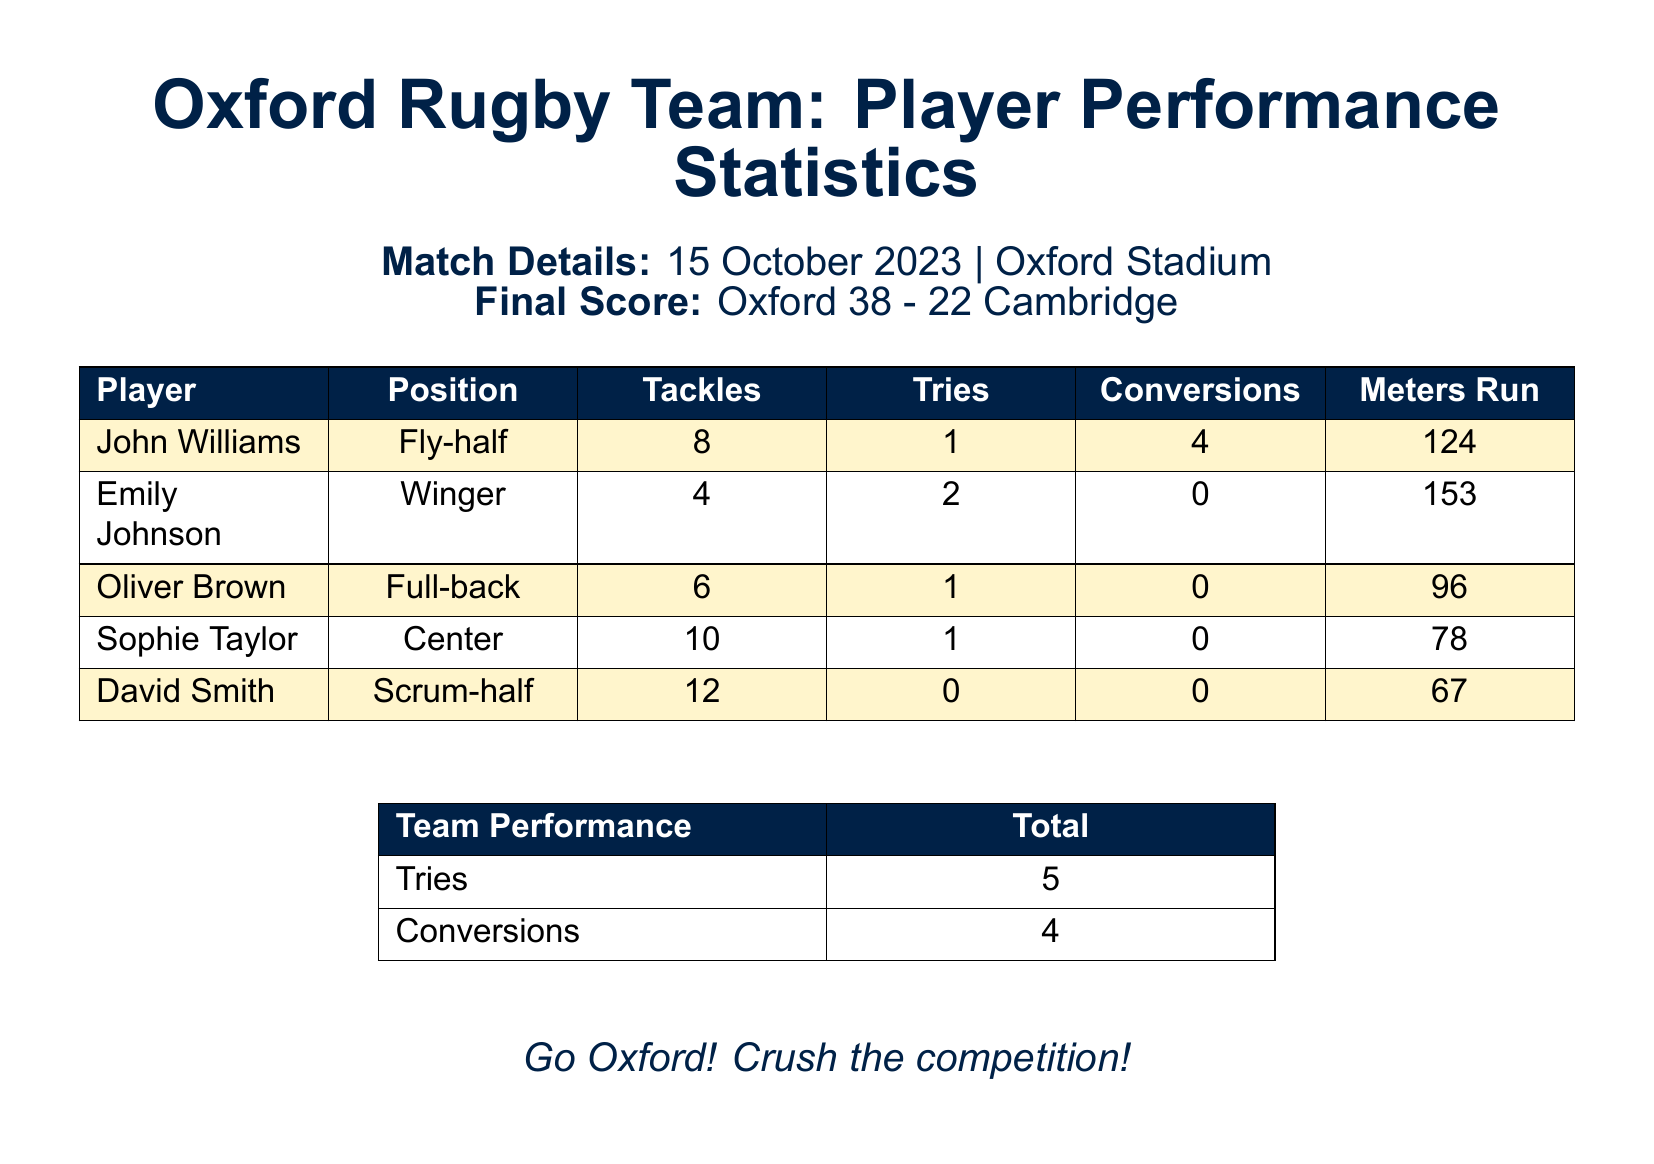What was the final score of the match? The final score of the match is explicitly stated in the document under match details.
Answer: Oxford 38 - 22 Cambridge How many tries did Oxford score? The total tries scored by Oxford is mentioned in the team performance section of the scorecard.
Answer: 5 Who had the highest number of tackles? The player with the highest number of tackles can be determined by comparing the tackle counts listed for each player.
Answer: David Smith How many conversions did John Williams make? The number of conversions made by John Williams is directly listed in his statistics section in the scorecard.
Answer: 4 What position does Emily Johnson play? The position of Emily Johnson is provided in the player statistics table.
Answer: Winger Which player ran the most meters? The player who ran the most meters can be identified by looking at the meters run column in the scorecard.
Answer: Emily Johnson What date was the match played? The date of the match is stated in the match details section of the document.
Answer: 15 October 2023 How many tackles did Sophie Taylor have? The number of tackles Sophie Taylor had can be found in her statistics listed in the scorecard.
Answer: 10 What was the total number of conversions by the team? The total number of conversions is summarized in the team performance section of the scorecard.
Answer: 4 